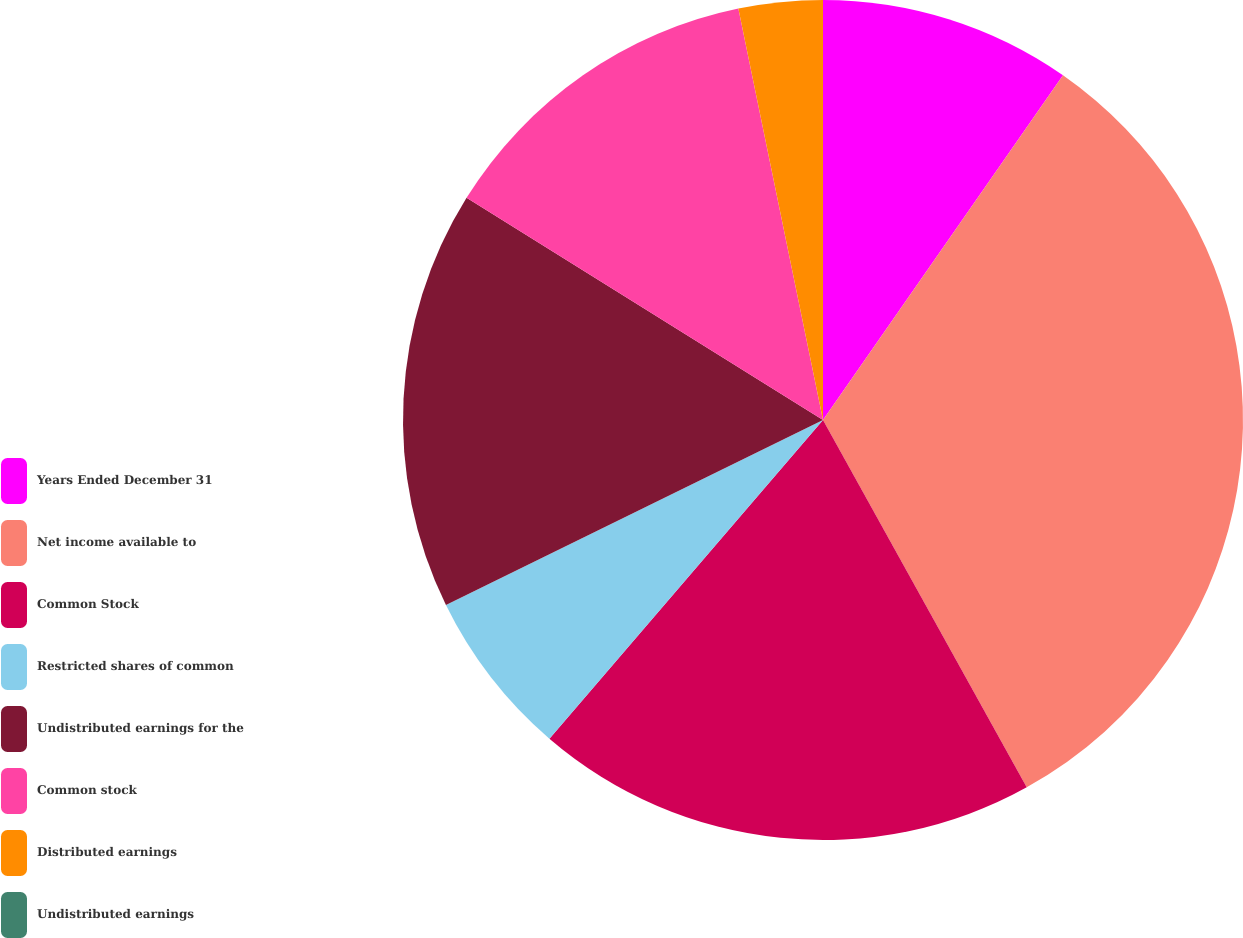<chart> <loc_0><loc_0><loc_500><loc_500><pie_chart><fcel>Years Ended December 31<fcel>Net income available to<fcel>Common Stock<fcel>Restricted shares of common<fcel>Undistributed earnings for the<fcel>Common stock<fcel>Distributed earnings<fcel>Undistributed earnings<nl><fcel>9.68%<fcel>32.26%<fcel>19.35%<fcel>6.45%<fcel>16.13%<fcel>12.9%<fcel>3.23%<fcel>0.0%<nl></chart> 